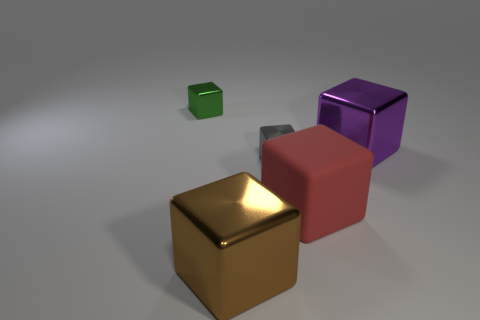Subtract all purple cubes. How many cubes are left? 4 Subtract all tiny gray cubes. How many cubes are left? 4 Subtract all purple blocks. Subtract all brown spheres. How many blocks are left? 4 Add 3 metal objects. How many objects exist? 8 Subtract 0 cyan cylinders. How many objects are left? 5 Subtract all large red things. Subtract all large objects. How many objects are left? 1 Add 2 tiny green metallic things. How many tiny green metallic things are left? 3 Add 4 small gray blocks. How many small gray blocks exist? 5 